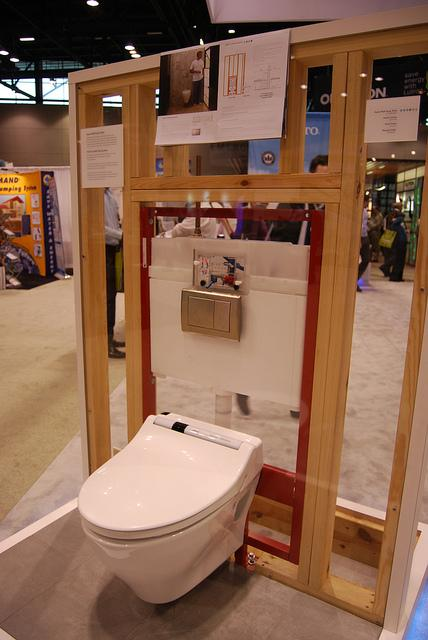Where is this toilet located? Please explain your reasoning. expo. This is the most likely place given that two of the other options wouldn't work and b would be enclosed. 